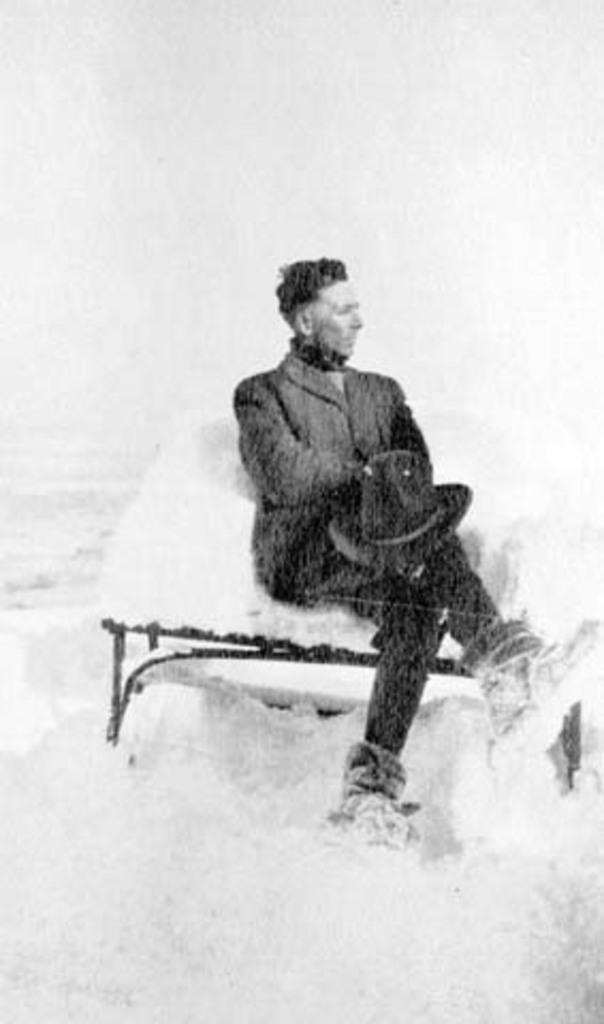What is the person in the image doing? There is a person sitting on a bench in the image. What is the person holding? The person is holding a hat. What is the weather like in the image? There is snow visible in the image, indicating a cold or wintry setting. What type of hammer is being used to test the frame in the image? There is no hammer or frame present in the image; it only features a person sitting on a bench and holding a hat. 